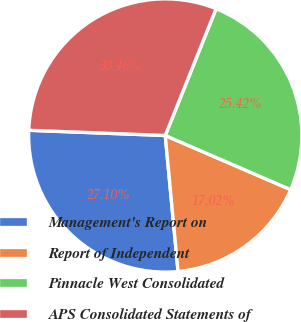Convert chart to OTSL. <chart><loc_0><loc_0><loc_500><loc_500><pie_chart><fcel>Management's Report on<fcel>Report of Independent<fcel>Pinnacle West Consolidated<fcel>APS Consolidated Statements of<nl><fcel>27.1%<fcel>17.02%<fcel>25.42%<fcel>30.46%<nl></chart> 